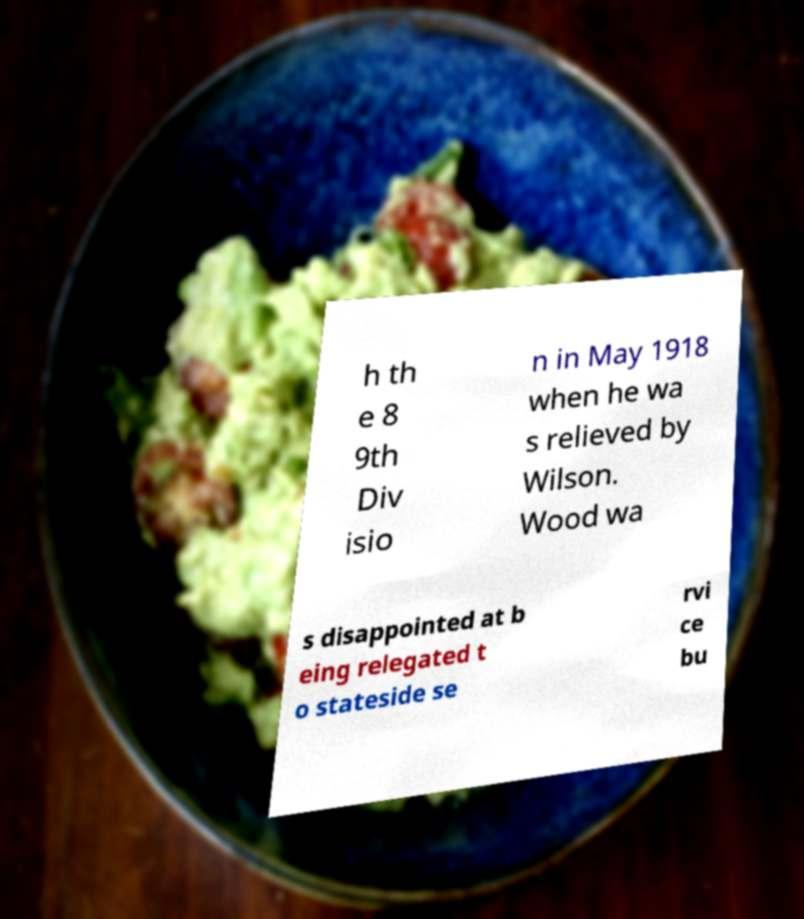Please read and relay the text visible in this image. What does it say? h th e 8 9th Div isio n in May 1918 when he wa s relieved by Wilson. Wood wa s disappointed at b eing relegated t o stateside se rvi ce bu 